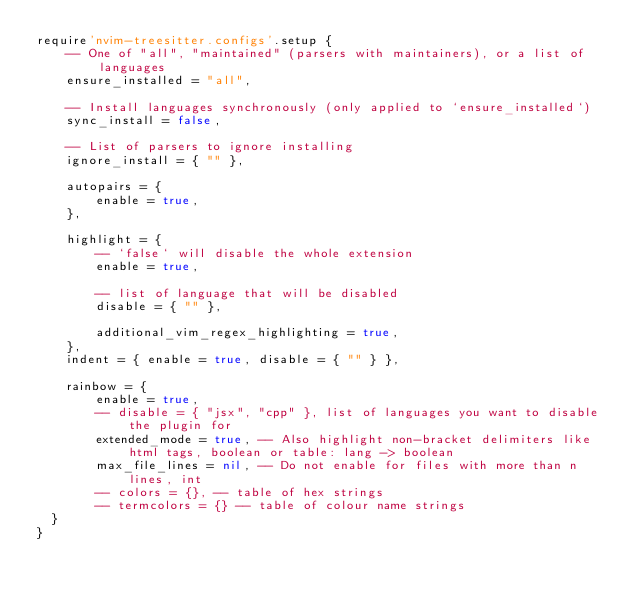Convert code to text. <code><loc_0><loc_0><loc_500><loc_500><_Lua_>require'nvim-treesitter.configs'.setup {
    -- One of "all", "maintained" (parsers with maintainers), or a list of languages
    ensure_installed = "all",

    -- Install languages synchronously (only applied to `ensure_installed`)
    sync_install = false,

    -- List of parsers to ignore installing
    ignore_install = { "" },

    autopairs = {
        enable = true,
    },

    highlight = {
        -- `false` will disable the whole extension
        enable = true,

        -- list of language that will be disabled
        disable = { "" },
 
        additional_vim_regex_highlighting = true,
    },
    indent = { enable = true, disable = { "" } },

    rainbow = {
        enable = true,
        -- disable = { "jsx", "cpp" }, list of languages you want to disable the plugin for
        extended_mode = true, -- Also highlight non-bracket delimiters like html tags, boolean or table: lang -> boolean
        max_file_lines = nil, -- Do not enable for files with more than n lines, int
        -- colors = {}, -- table of hex strings
        -- termcolors = {} -- table of colour name strings
  }
}
</code> 